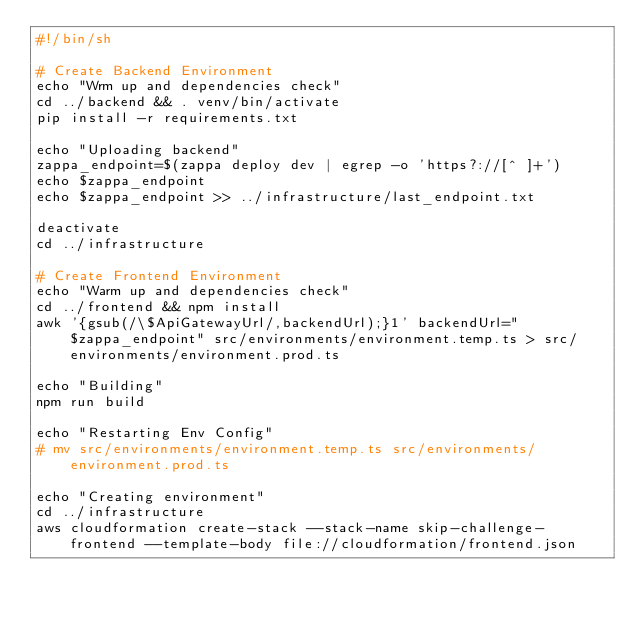<code> <loc_0><loc_0><loc_500><loc_500><_Bash_>#!/bin/sh

# Create Backend Environment
echo "Wrm up and dependencies check"
cd ../backend && . venv/bin/activate
pip install -r requirements.txt

echo "Uploading backend"
zappa_endpoint=$(zappa deploy dev | egrep -o 'https?://[^ ]+')
echo $zappa_endpoint
echo $zappa_endpoint >> ../infrastructure/last_endpoint.txt

deactivate
cd ../infrastructure

# Create Frontend Environment
echo "Warm up and dependencies check"
cd ../frontend && npm install
awk '{gsub(/\$ApiGatewayUrl/,backendUrl);}1' backendUrl="$zappa_endpoint" src/environments/environment.temp.ts > src/environments/environment.prod.ts

echo "Building"
npm run build

echo "Restarting Env Config"
# mv src/environments/environment.temp.ts src/environments/environment.prod.ts

echo "Creating environment"
cd ../infrastructure
aws cloudformation create-stack --stack-name skip-challenge-frontend --template-body file://cloudformation/frontend.json</code> 